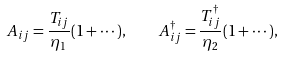<formula> <loc_0><loc_0><loc_500><loc_500>A _ { i j } = \frac { T _ { i j } } { \eta _ { 1 } } ( 1 + \cdots ) , \quad A ^ { \dagger } _ { i j } = \frac { T ^ { \dagger } _ { i j } } { \eta _ { 2 } } ( 1 + \cdots ) ,</formula> 